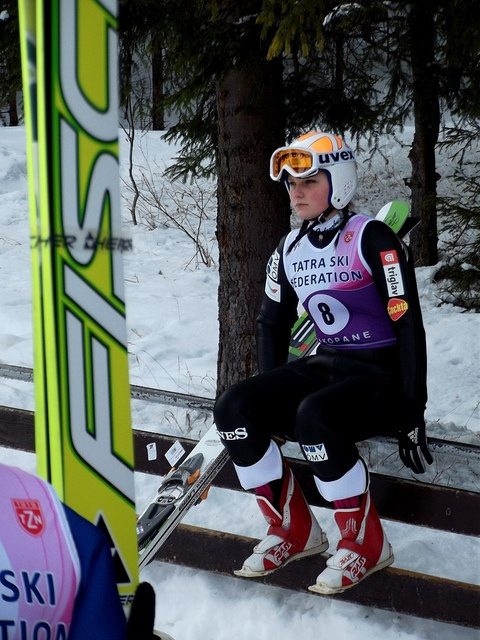Describe the objects in this image and their specific colors. I can see people in black, darkgray, and maroon tones, skis in black, darkgray, olive, and darkgreen tones, people in black, violet, navy, and purple tones, and skis in black, gray, darkgray, and lightgray tones in this image. 